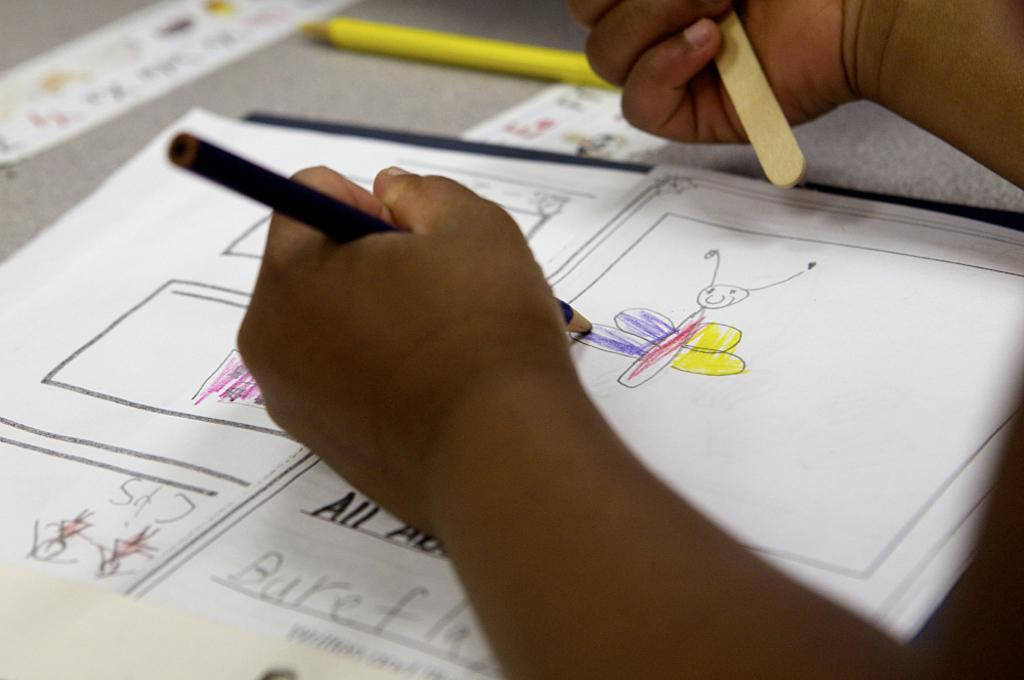<image>
Summarize the visual content of the image. Person drawing a butterfly with their hand above the word "ALL". 